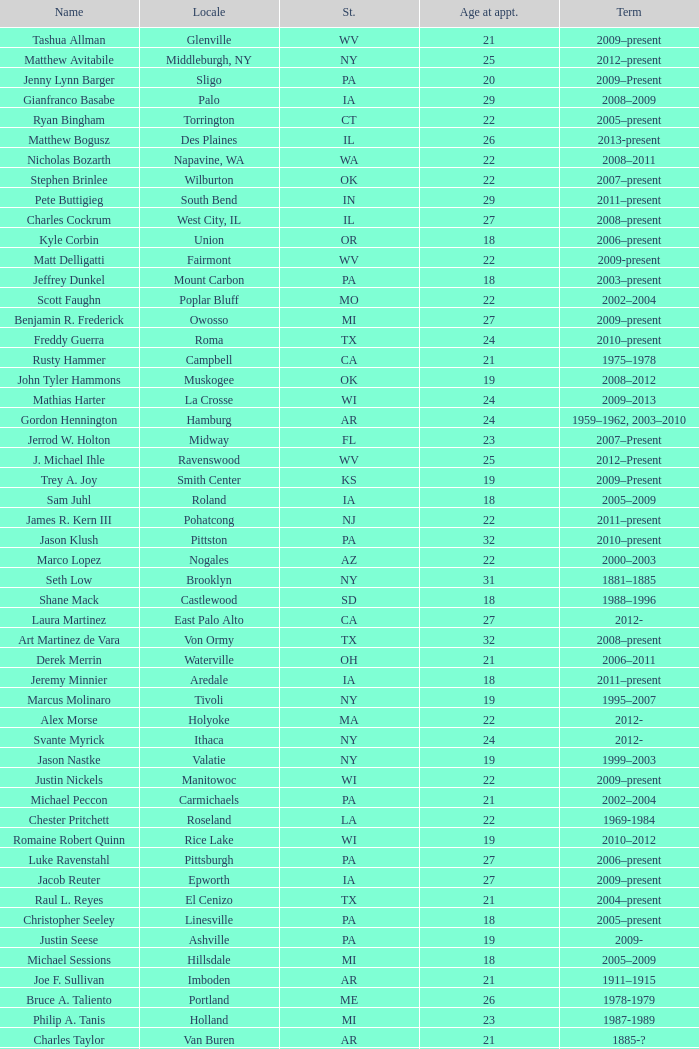What is the name of the holland locale Philip A. Tanis. 